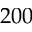<formula> <loc_0><loc_0><loc_500><loc_500>2 0 0</formula> 